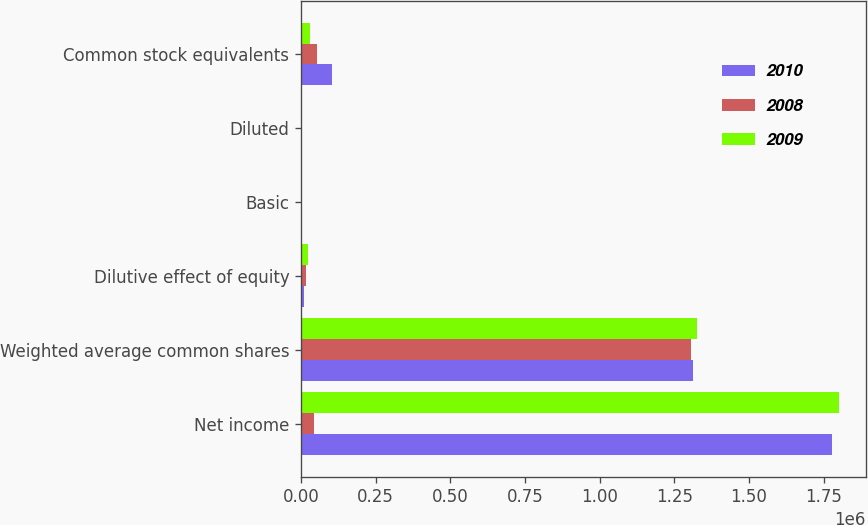Convert chart. <chart><loc_0><loc_0><loc_500><loc_500><stacked_bar_chart><ecel><fcel>Net income<fcel>Weighted average common shares<fcel>Dilutive effect of equity<fcel>Basic<fcel>Diluted<fcel>Common stock equivalents<nl><fcel>2010<fcel>1.77947e+06<fcel>1.31261e+06<fcel>9154<fcel>1.37<fcel>1.36<fcel>102642<nl><fcel>2008<fcel>42267.5<fcel>1.30498e+06<fcel>15133<fcel>1.85<fcel>1.83<fcel>53026<nl><fcel>2009<fcel>1.80096e+06<fcel>1.32742e+06<fcel>21824<fcel>1.38<fcel>1.36<fcel>31509<nl></chart> 